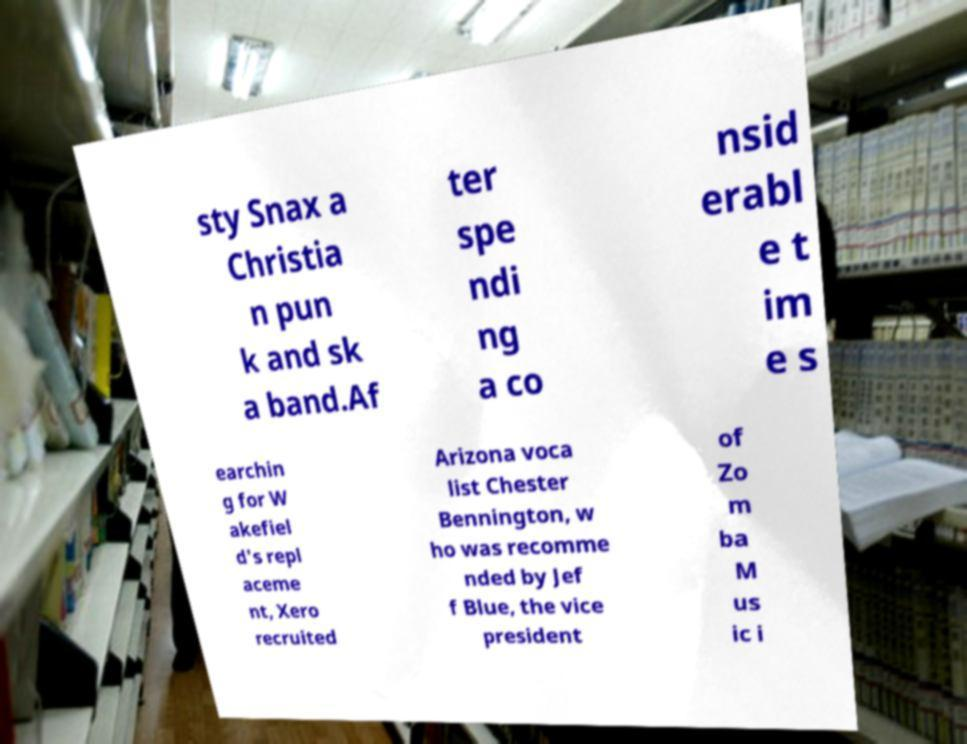Could you assist in decoding the text presented in this image and type it out clearly? sty Snax a Christia n pun k and sk a band.Af ter spe ndi ng a co nsid erabl e t im e s earchin g for W akefiel d's repl aceme nt, Xero recruited Arizona voca list Chester Bennington, w ho was recomme nded by Jef f Blue, the vice president of Zo m ba M us ic i 